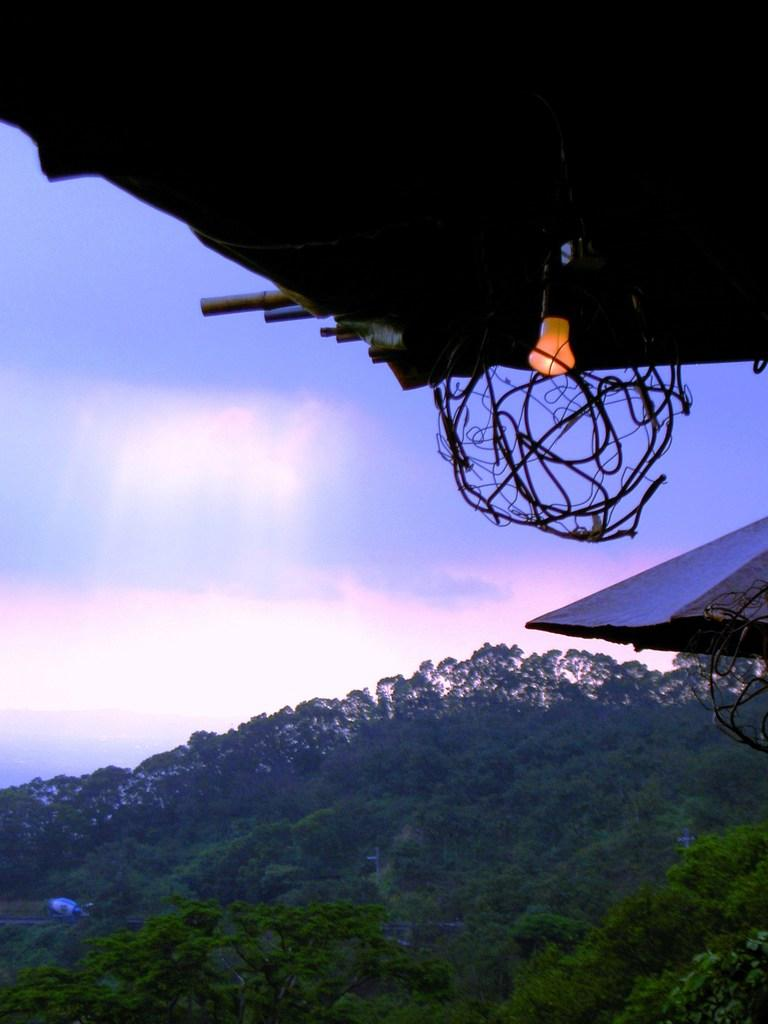What type of vegetation can be seen in the image? There are trees in the image. What color are the trees? The trees are green in color. What can be seen in the background of the image? The sky is blue and white in color in the background. Is there any source of light visible in the image? Yes, there is light visible in the image. What type of quarter is depicted in the image? There is no quarter present in the image; it features trees, light, and a blue and white sky. What type of beast can be seen hiding among the trees in the image? There is no beast present in the image; it only features trees, light, and a blue and white sky. 